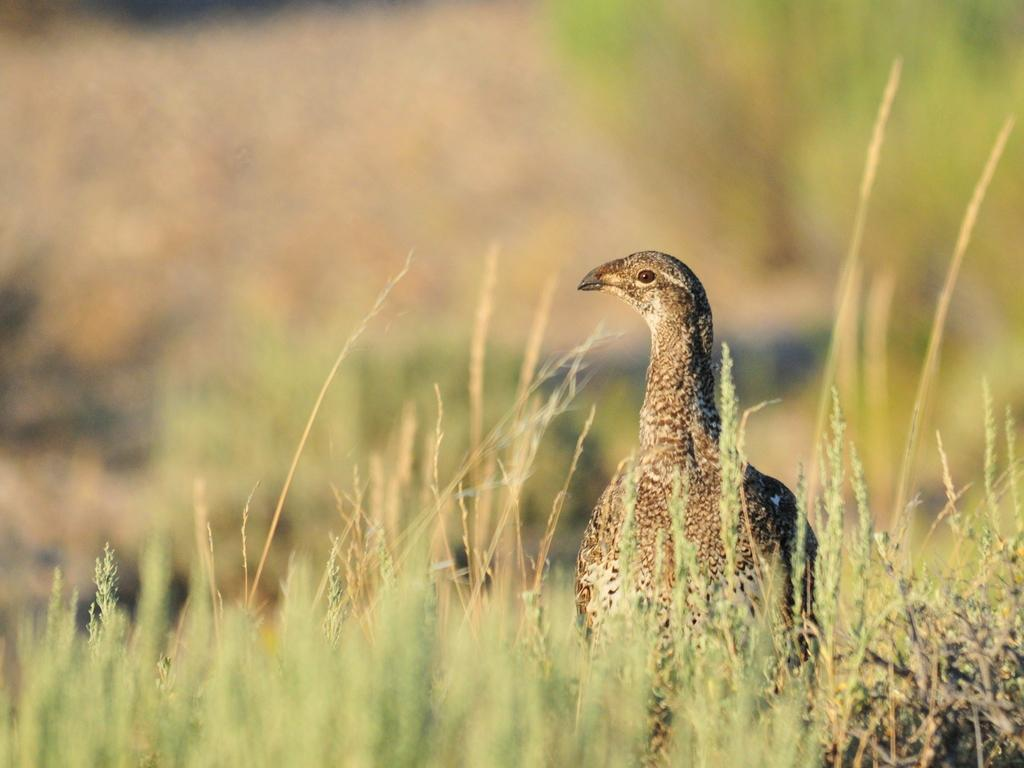What type of living organisms can be seen in the image? Plants can be seen in the image. Can any animals be identified in the image? Yes, there is a bird at the bottom of the image. What type of cable is being used by the bird in the image? There is no cable present in the image, and the bird is not using any cable. What scientific discovery is being made by the plants in the image? The image does not depict any scientific discovery being made by the plants; they are simply plants. 